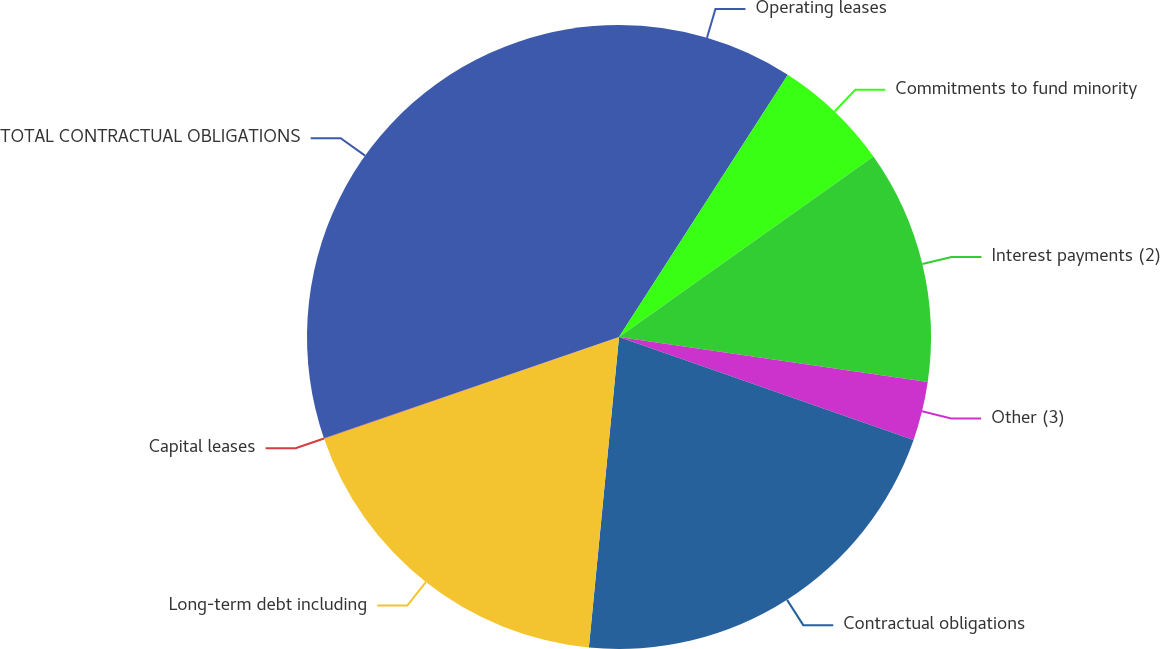<chart> <loc_0><loc_0><loc_500><loc_500><pie_chart><fcel>Operating leases<fcel>Commitments to fund minority<fcel>Interest payments (2)<fcel>Other (3)<fcel>Contractual obligations<fcel>Long-term debt including<fcel>Capital leases<fcel>TOTAL CONTRACTUAL OBLIGATIONS<nl><fcel>9.1%<fcel>6.08%<fcel>12.12%<fcel>3.05%<fcel>21.19%<fcel>18.17%<fcel>0.03%<fcel>30.26%<nl></chart> 